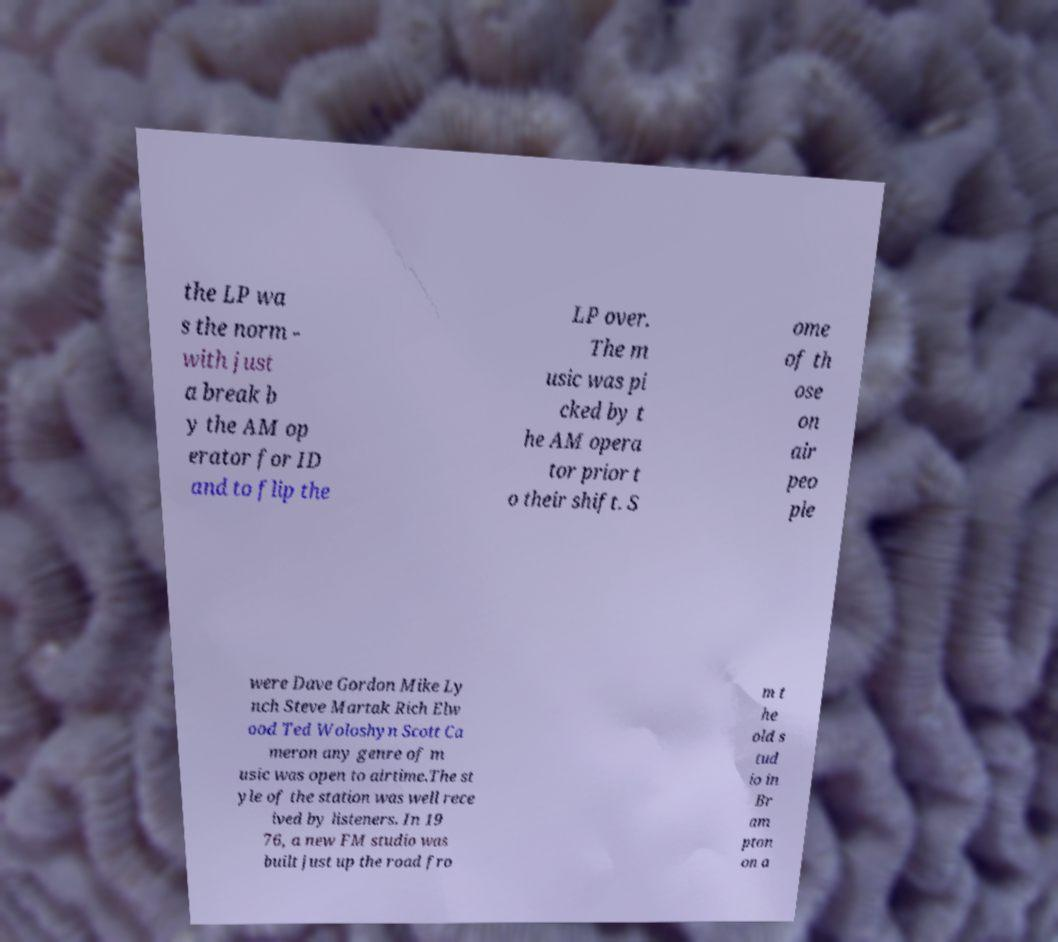For documentation purposes, I need the text within this image transcribed. Could you provide that? the LP wa s the norm - with just a break b y the AM op erator for ID and to flip the LP over. The m usic was pi cked by t he AM opera tor prior t o their shift. S ome of th ose on air peo ple were Dave Gordon Mike Ly nch Steve Martak Rich Elw ood Ted Woloshyn Scott Ca meron any genre of m usic was open to airtime.The st yle of the station was well rece ived by listeners. In 19 76, a new FM studio was built just up the road fro m t he old s tud io in Br am pton on a 